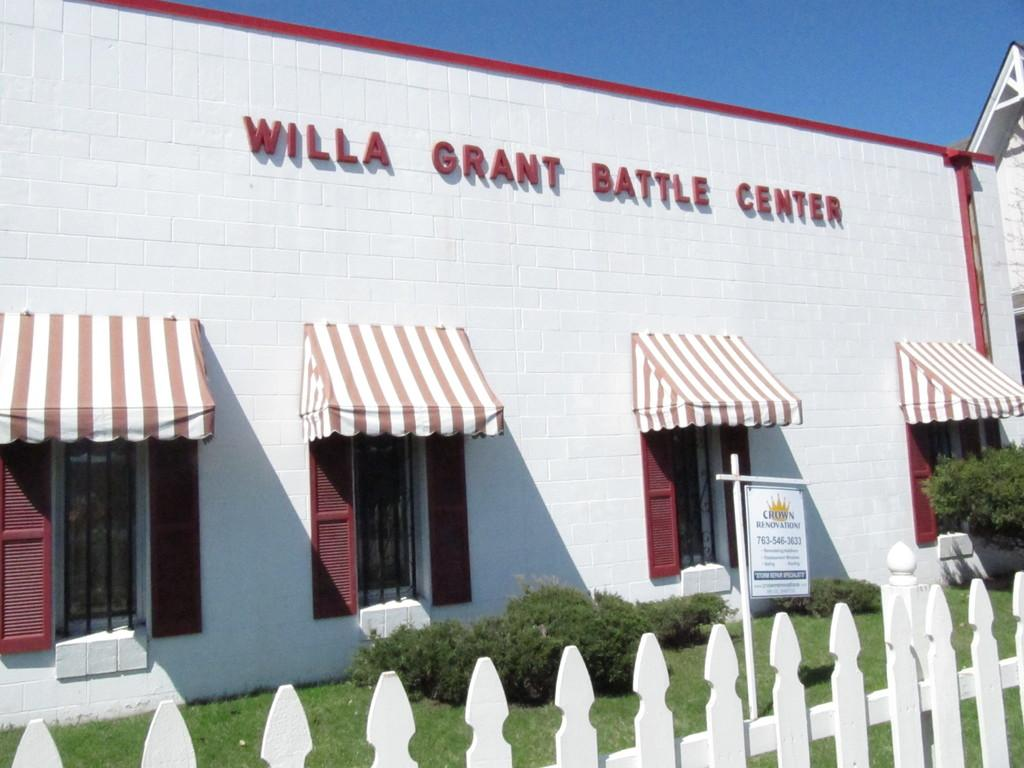What type of structure is visible in the image? There is a building in the image. What is the board used for in the image? The purpose of the board in the image is not specified, but it is present. What type of vegetation is in the image? There are plants in the image. What feature allows light to enter the building in the image? There are windows in the image that allow light to enter. What type of barrier is present in the image? There is a fence in the image. What type of apparatus is being used by the son in the image? There is no son or apparatus present in the image. What type of glove is being worn by the person in the image? There is no person or glove present in the image. 